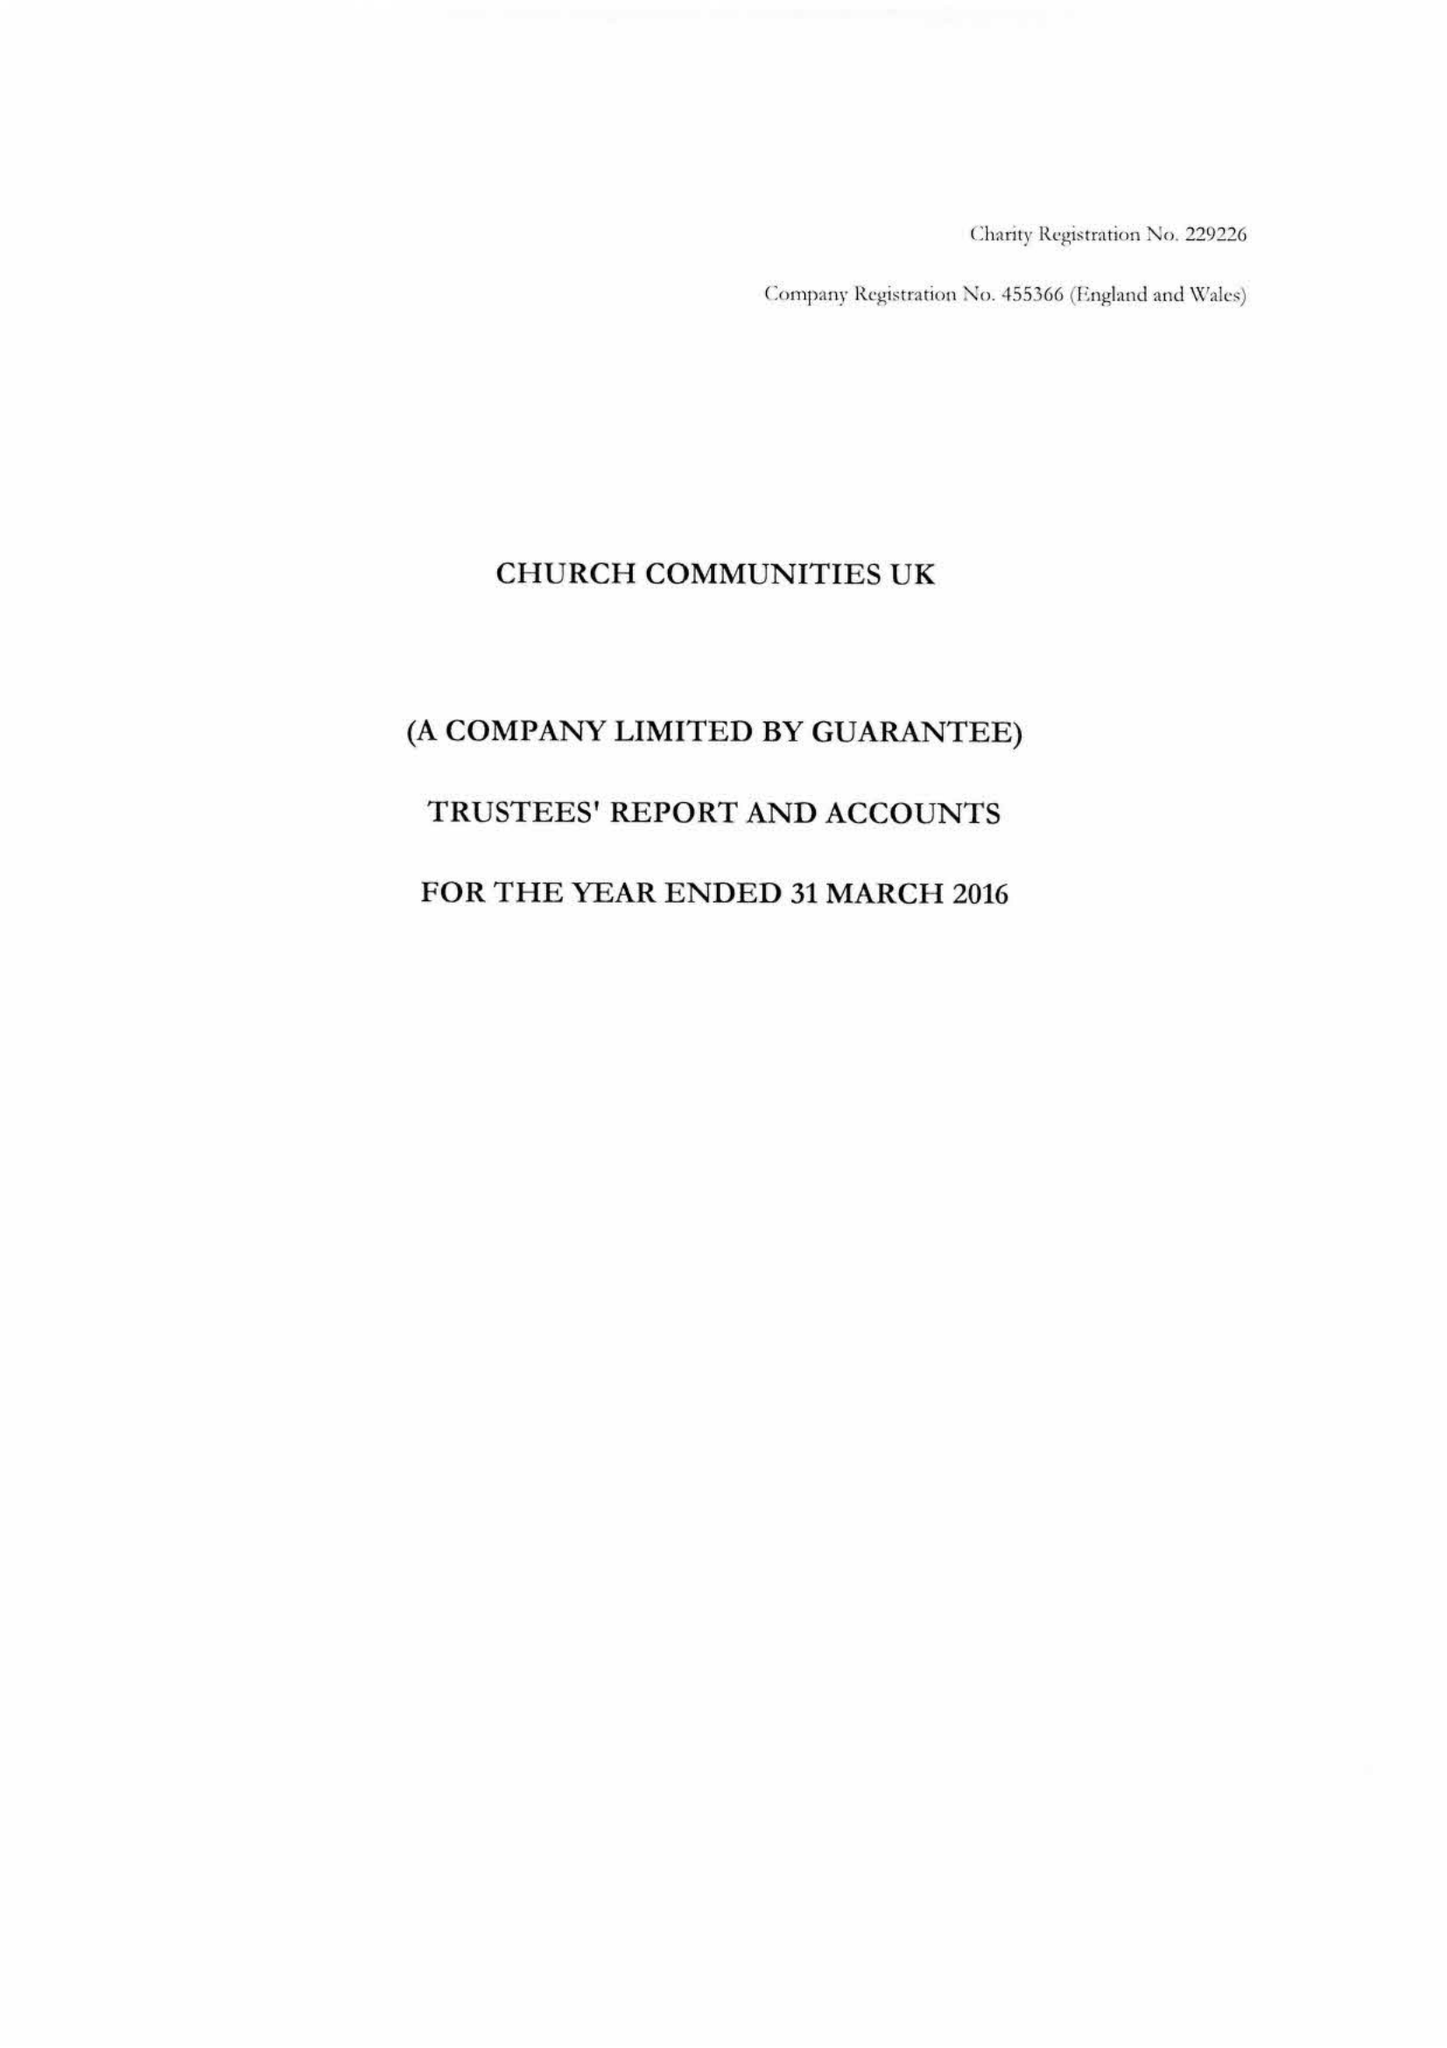What is the value for the income_annually_in_british_pounds?
Answer the question using a single word or phrase. 24131564.00 